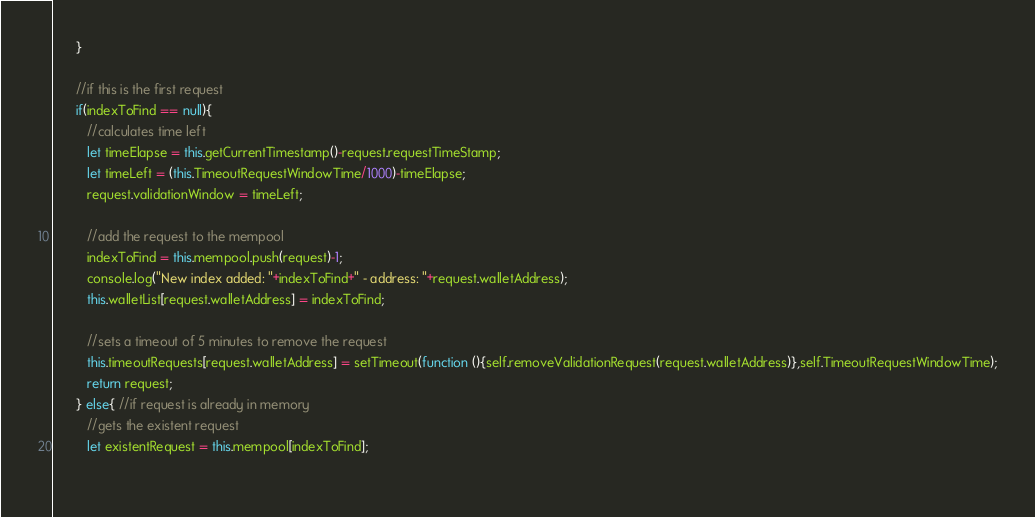<code> <loc_0><loc_0><loc_500><loc_500><_JavaScript_>      }

      //if this is the first request
      if(indexToFind == null){
         //calculates time left
         let timeElapse = this.getCurrentTimestamp()-request.requestTimeStamp;
         let timeLeft = (this.TimeoutRequestWindowTime/1000)-timeElapse;
         request.validationWindow = timeLeft;

         //add the request to the mempool
         indexToFind = this.mempool.push(request)-1;
         console.log("New index added: "+indexToFind+" - address: "+request.walletAddress);
         this.walletList[request.walletAddress] = indexToFind;

         //sets a timeout of 5 minutes to remove the request
         this.timeoutRequests[request.walletAddress] = setTimeout(function (){self.removeValidationRequest(request.walletAddress)},self.TimeoutRequestWindowTime);
         return request;     
      } else{ //if request is already in memory
         //gets the existent request
         let existentRequest = this.mempool[indexToFind];
         </code> 